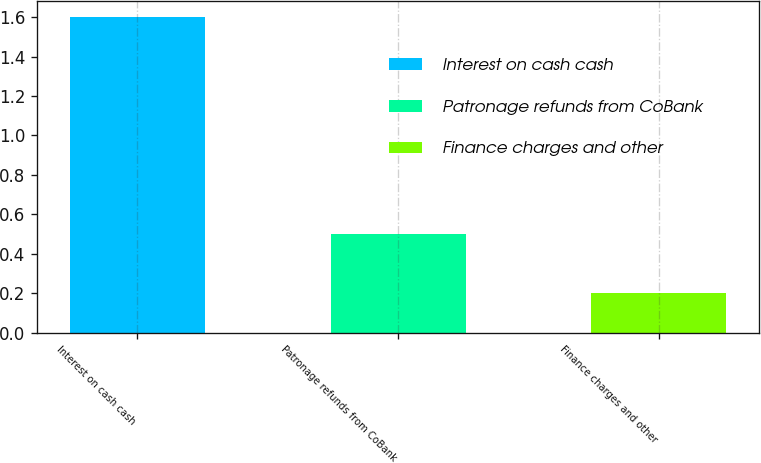Convert chart to OTSL. <chart><loc_0><loc_0><loc_500><loc_500><bar_chart><fcel>Interest on cash cash<fcel>Patronage refunds from CoBank<fcel>Finance charges and other<nl><fcel>1.6<fcel>0.5<fcel>0.2<nl></chart> 